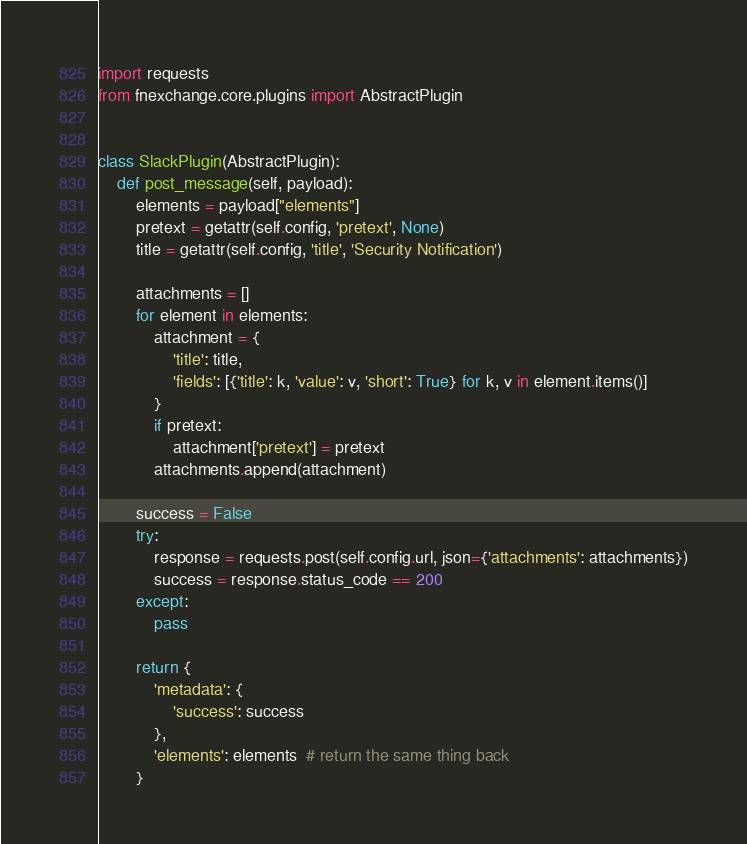Convert code to text. <code><loc_0><loc_0><loc_500><loc_500><_Python_>import requests
from fnexchange.core.plugins import AbstractPlugin


class SlackPlugin(AbstractPlugin):
    def post_message(self, payload):
        elements = payload["elements"]
        pretext = getattr(self.config, 'pretext', None)
        title = getattr(self.config, 'title', 'Security Notification')

        attachments = []
        for element in elements:
            attachment = {
                'title': title,
                'fields': [{'title': k, 'value': v, 'short': True} for k, v in element.items()]
            }
            if pretext:
                attachment['pretext'] = pretext
            attachments.append(attachment)

        success = False
        try:
            response = requests.post(self.config.url, json={'attachments': attachments})
            success = response.status_code == 200
        except:
            pass

        return {
            'metadata': {
                'success': success
            },
            'elements': elements  # return the same thing back
        }
</code> 